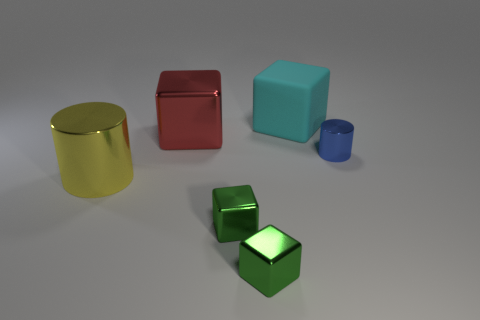Add 2 tiny red matte spheres. How many objects exist? 8 Subtract all cubes. How many objects are left? 2 Add 5 yellow things. How many yellow things are left? 6 Add 4 big red metallic objects. How many big red metallic objects exist? 5 Subtract 1 blue cylinders. How many objects are left? 5 Subtract all yellow metallic cylinders. Subtract all small green cubes. How many objects are left? 3 